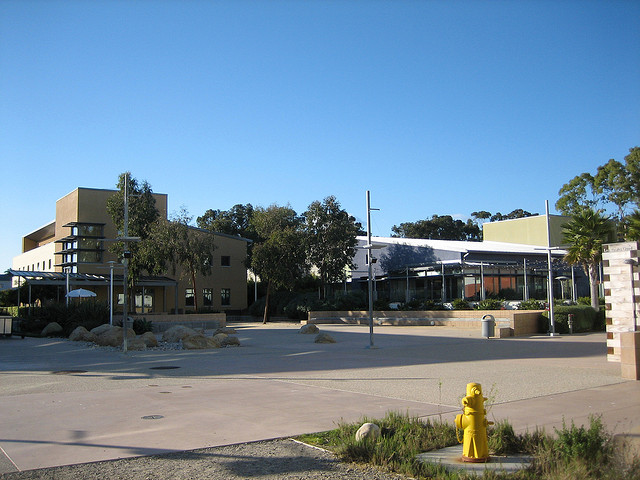Can you describe the landscape and vegetation in the area? The landscape is well-manicured with patches of grass and neatly arranged shrubbery. A variety of trees can be seen, which provide shade and contribute to the serene atmosphere of the area. 